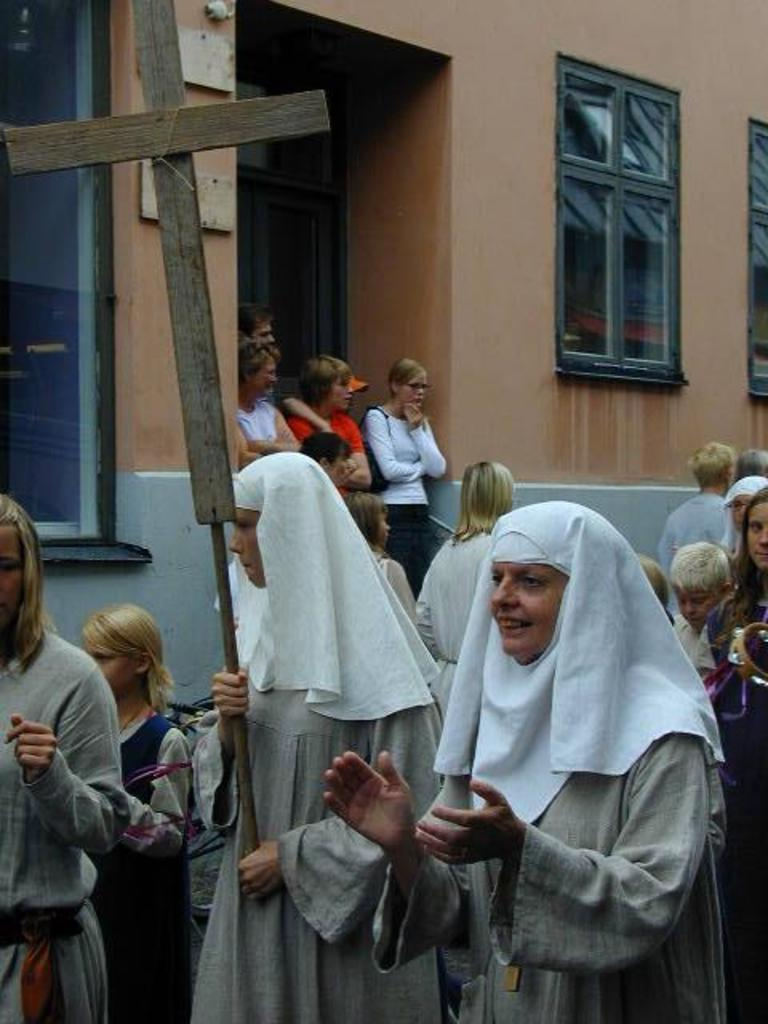How many people are in the image? There is a group of people standing in the image. What is the woman holding in the image? The woman is holding a cross with a pole. What can be seen in the background of the image? There is a building with windows in the background of the image. Where is the frog sitting in the image? There is no frog present in the image. What type of swing can be seen in the image? There is no swing present in the image. 